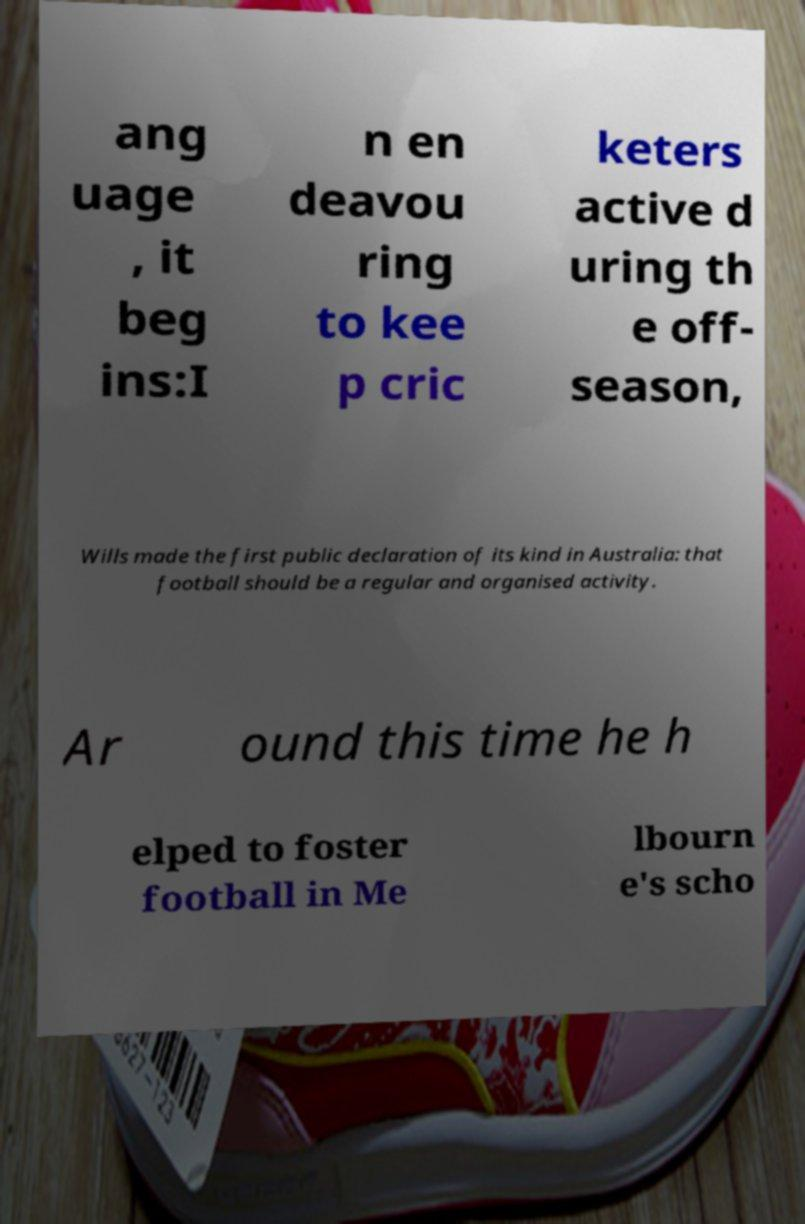Can you read and provide the text displayed in the image?This photo seems to have some interesting text. Can you extract and type it out for me? ang uage , it beg ins:I n en deavou ring to kee p cric keters active d uring th e off- season, Wills made the first public declaration of its kind in Australia: that football should be a regular and organised activity. Ar ound this time he h elped to foster football in Me lbourn e's scho 